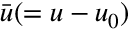<formula> <loc_0><loc_0><loc_500><loc_500>{ \bar { u } } ( = { u } - { u } _ { 0 } )</formula> 